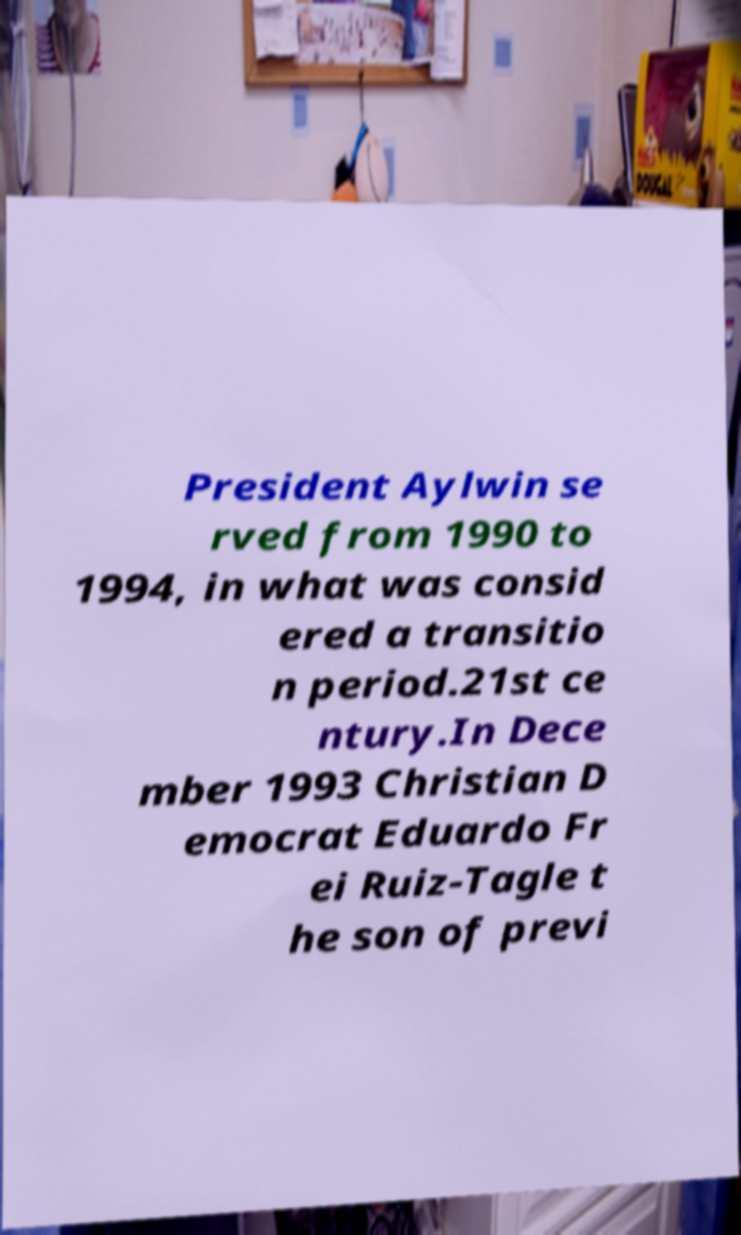Could you assist in decoding the text presented in this image and type it out clearly? President Aylwin se rved from 1990 to 1994, in what was consid ered a transitio n period.21st ce ntury.In Dece mber 1993 Christian D emocrat Eduardo Fr ei Ruiz-Tagle t he son of previ 